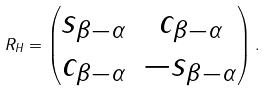<formula> <loc_0><loc_0><loc_500><loc_500>R _ { H } = \begin{pmatrix} s _ { \beta - \alpha } & c _ { \beta - \alpha } \\ c _ { \beta - \alpha } & - s _ { \beta - \alpha } \end{pmatrix} .</formula> 